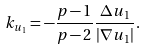Convert formula to latex. <formula><loc_0><loc_0><loc_500><loc_500>k _ { u _ { 1 } } = - \frac { p - 1 } { p - 2 } \frac { \Delta u _ { 1 } } { | \nabla u _ { 1 } | } .</formula> 